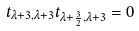Convert formula to latex. <formula><loc_0><loc_0><loc_500><loc_500>t _ { \lambda + 3 , \lambda + 3 } t _ { \lambda + \frac { 3 } { 2 } , \lambda + 3 } = 0</formula> 